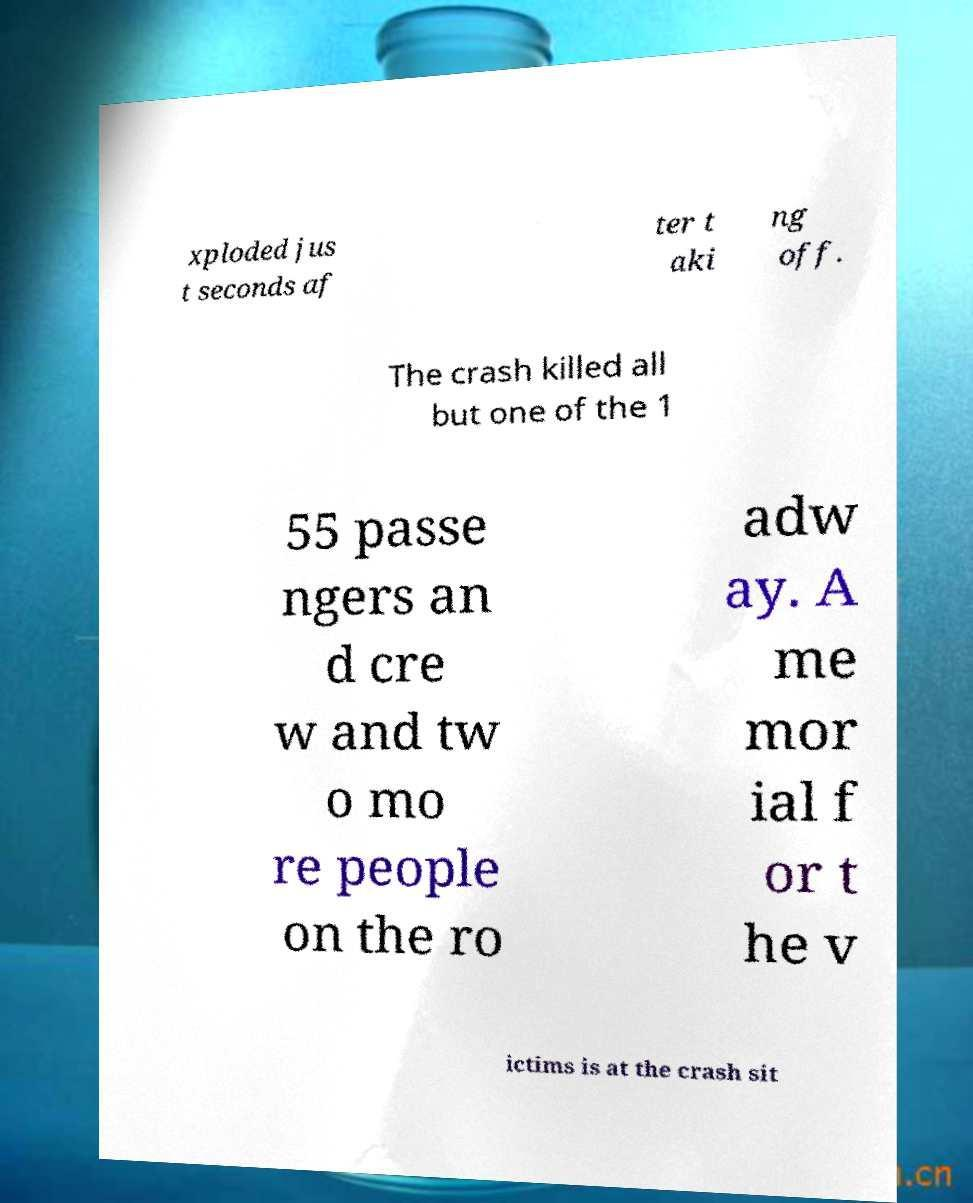Could you assist in decoding the text presented in this image and type it out clearly? xploded jus t seconds af ter t aki ng off. The crash killed all but one of the 1 55 passe ngers an d cre w and tw o mo re people on the ro adw ay. A me mor ial f or t he v ictims is at the crash sit 